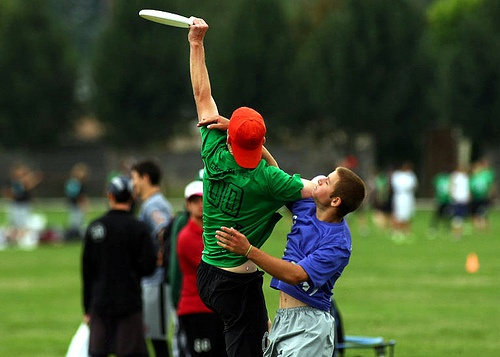Describe the objects in this image and their specific colors. I can see people in darkgreen, black, tan, and red tones, people in darkgreen, black, navy, darkblue, and darkgray tones, people in darkgreen, black, gray, white, and maroon tones, people in darkgreen, black, brown, maroon, and white tones, and people in darkgreen, lightblue, olive, black, and darkgray tones in this image. 